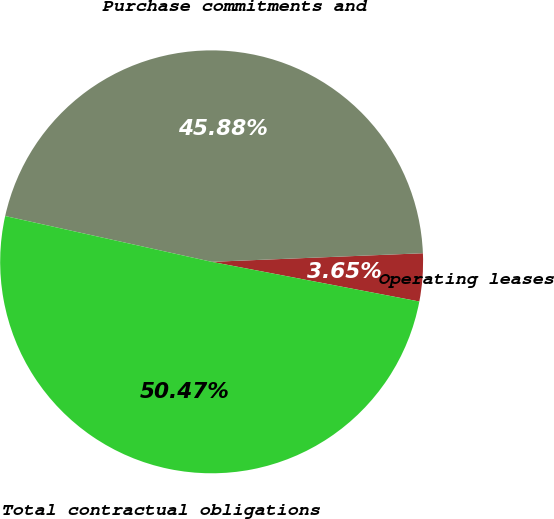<chart> <loc_0><loc_0><loc_500><loc_500><pie_chart><fcel>Operating leases<fcel>Purchase commitments and<fcel>Total contractual obligations<nl><fcel>3.65%<fcel>45.88%<fcel>50.47%<nl></chart> 